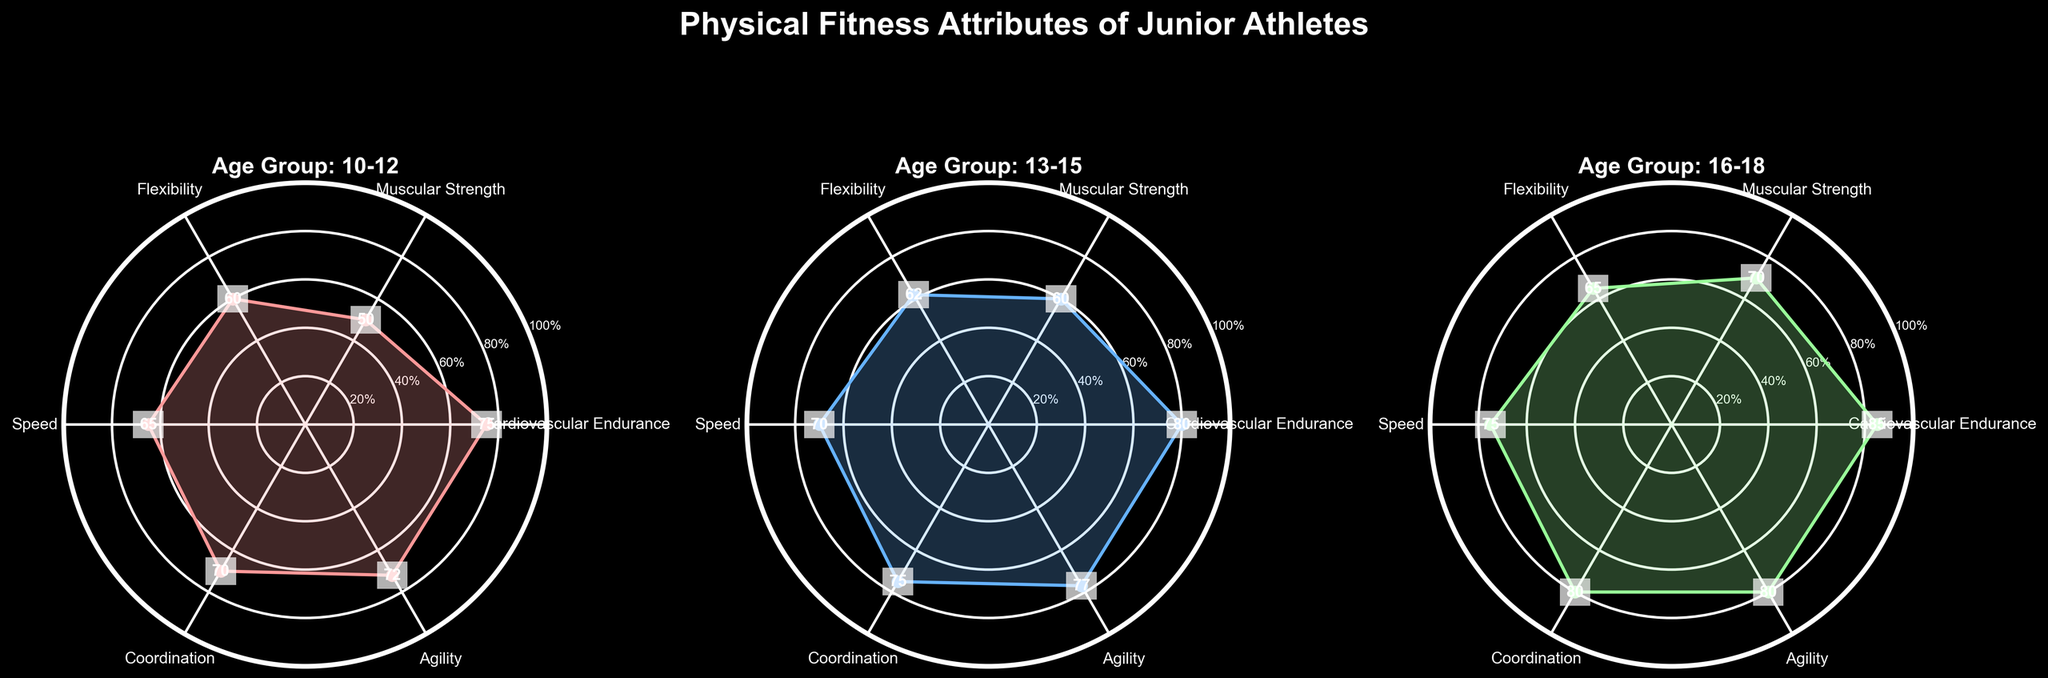What's the title of the overall figure? The title of the overall figure is displayed at the top and reads "Physical Fitness Attributes of Junior Athletes."
Answer: Physical Fitness Attributes of Junior Athletes In the 16-18 age group, what is the score for Cardiovascular Endurance? Refer to the radar chart showing the 16-18 age group. The value for Cardiovascular Endurance is the first score stated and is marked on the respective axis.
Answer: 85 Which age group has the highest score in Muscular Strength? Observe the scores for Muscular Strength in all age groups. The 16-18 age group shows a score of 70, which is higher than the scores of the other age groups (10-12 has 50, 13-15 has 60).
Answer: 16-18 Between the age groups 10-12 and 16-18, which one shows better performance in Speed? Look at the Speed scores for both 10-12 and 16-18 age groups. The score for the 10-12 group is 65, and for the 16-18 group, it's 75. Since 75 is higher than 65, 16-18 shows better performance.
Answer: 16-18 Comparing Cardiovascular Endurance and Flexibility, in which attribute does the 13-15 age group score higher? In the 13-15 age group, Cardiovascular Endurance is 80 and Flexibility is 62. Since 80 is higher than 62, the score is higher in Cardiovascular Endurance.
Answer: Cardiovascular Endurance What's the average score of Physical Fitness Attributes in the 10-12 age group? Sum all the scores for the 10-12 age group (75, 50, 60, 65, 70, 72), which equals 392. Dividing 392 by the number of attributes (6) gives an average.
Answer: 65.33 What's the difference in Coordination scores between age groups 10-12 and 16-18? The score for Coordination in the 10-12 group is 70, and in the 16-18 group, it's 80. Subtract 70 from 80.
Answer: 10 Which attribute shows a steady increase across all age groups? Check the scores for each attribute across all age groups and identify the one that consistently increases. Cardiovascular Endurance (75, 80, 85) shows a steady increase.
Answer: Cardiovascular Endurance For the 13-15 age group, which physical attribute has the lowest score? Check the scores for all attributes in the 13-15 age group and identify the smallest value. Muscular Strength has the lowest score of 60.
Answer: Muscular Strength 